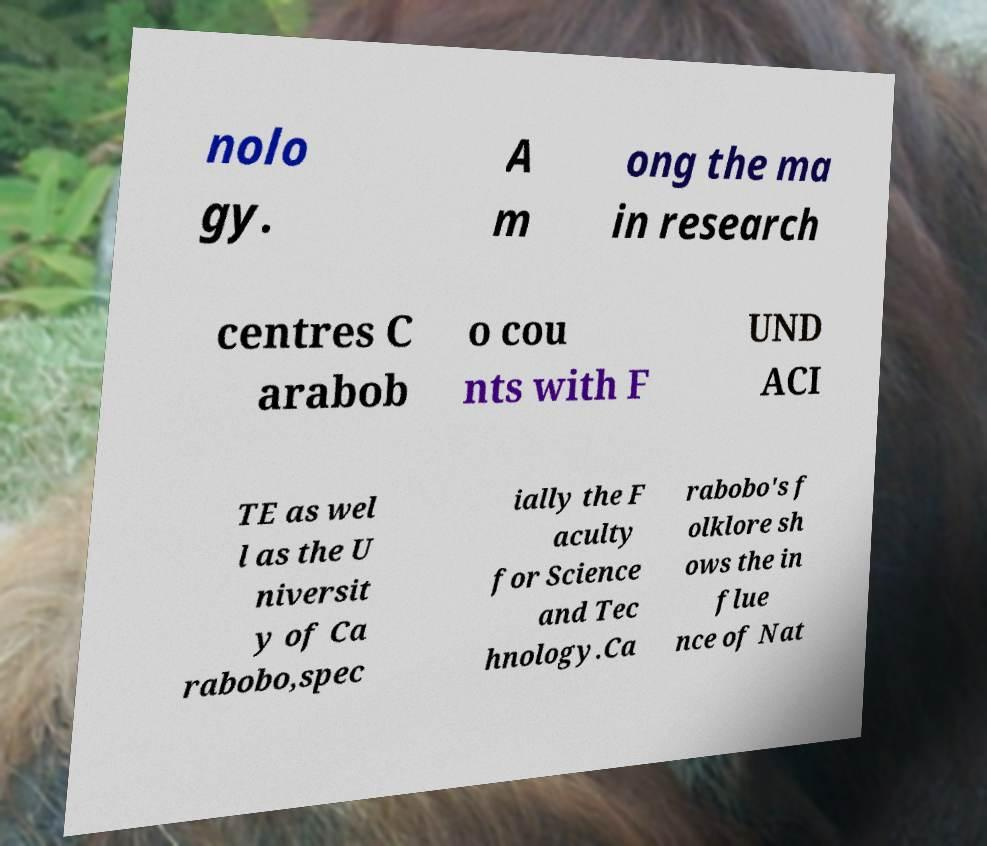Could you assist in decoding the text presented in this image and type it out clearly? nolo gy. A m ong the ma in research centres C arabob o cou nts with F UND ACI TE as wel l as the U niversit y of Ca rabobo,spec ially the F aculty for Science and Tec hnology.Ca rabobo's f olklore sh ows the in flue nce of Nat 